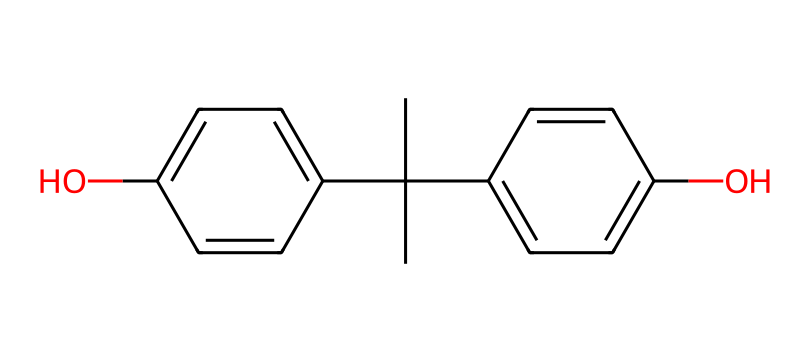What is the molecular formula of bisphenol A? To determine the molecular formula, the number of each type of atom in the structure must be counted. The chemical contains 15 carbon (C) atoms, 16 hydrogen (H) atoms, and 2 oxygen (O) atoms. Thus, the molecular formula is C15H16O2.
Answer: C15H16O2 How many hydroxyl groups are present in bisphenol A? Observing the chemical structure, there are two distinct -OH (hydroxyl) groups attached to the aromatic rings. Thus, bisphenol A has two hydroxyl groups.
Answer: 2 What type of chemical compound is bisphenol A? Bisphenol A features two phenolic structures joined by a bridge, which categorizes it as a phenol. This is distinct from other types of compounds, confirming its classification.
Answer: phenol What is the total number of rings in bisphenol A? Upon analyzing the structure, it consists of two aromatic rings that indicate its complexity. The two rings contribute to the overall cyclic nature of the molecule.
Answer: 2 Which functional group is primarily responsible for the solubility of bisphenol A in water? The presence of the hydroxyl (-OH) functional group in bisphenol A significantly contributes to its polar nature, enhancing its solubility in water.
Answer: hydroxyl group 